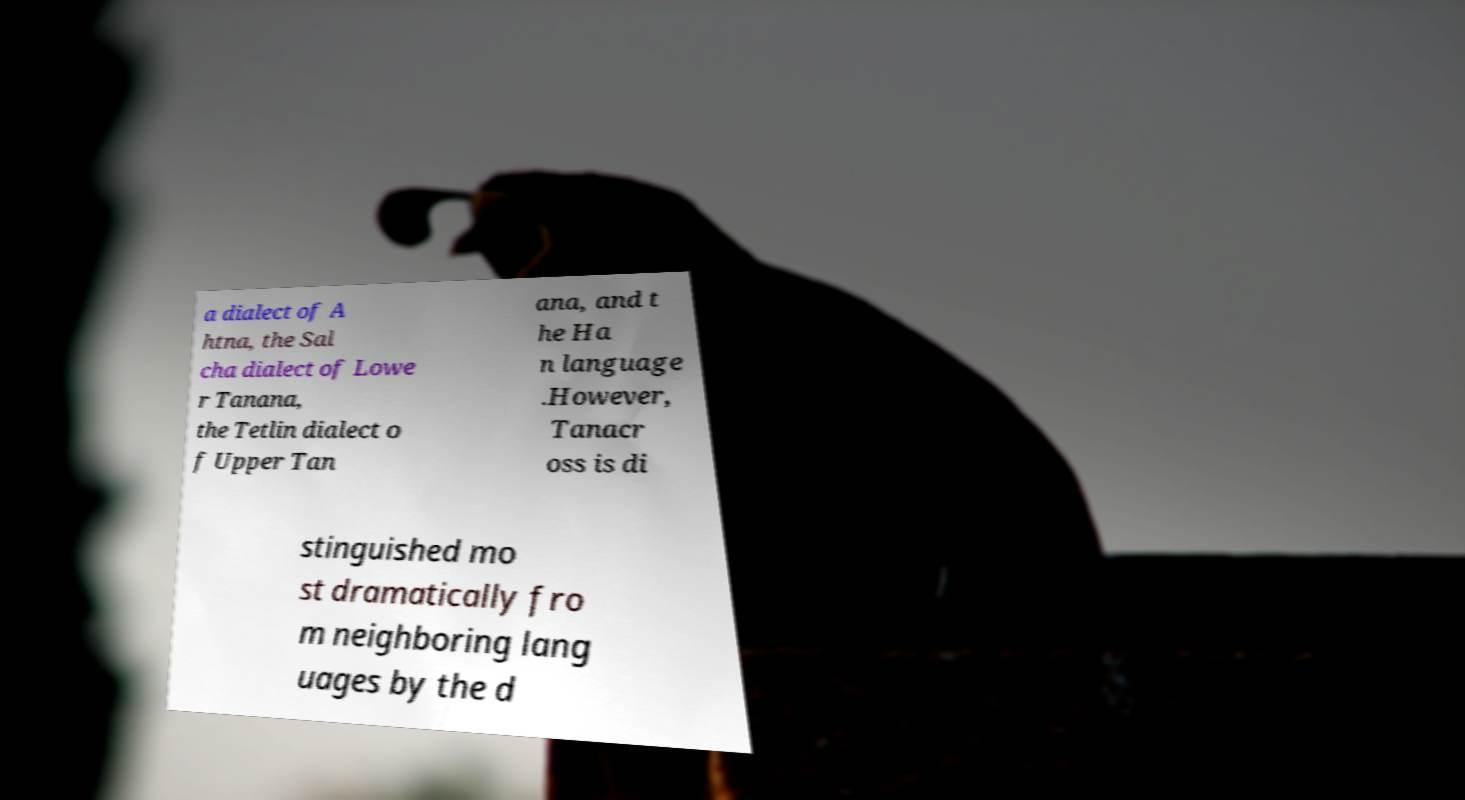Could you extract and type out the text from this image? a dialect of A htna, the Sal cha dialect of Lowe r Tanana, the Tetlin dialect o f Upper Tan ana, and t he Ha n language .However, Tanacr oss is di stinguished mo st dramatically fro m neighboring lang uages by the d 